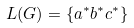<formula> <loc_0><loc_0><loc_500><loc_500>L ( G ) = \{ a ^ { * } b ^ { * } c ^ { * } \}</formula> 